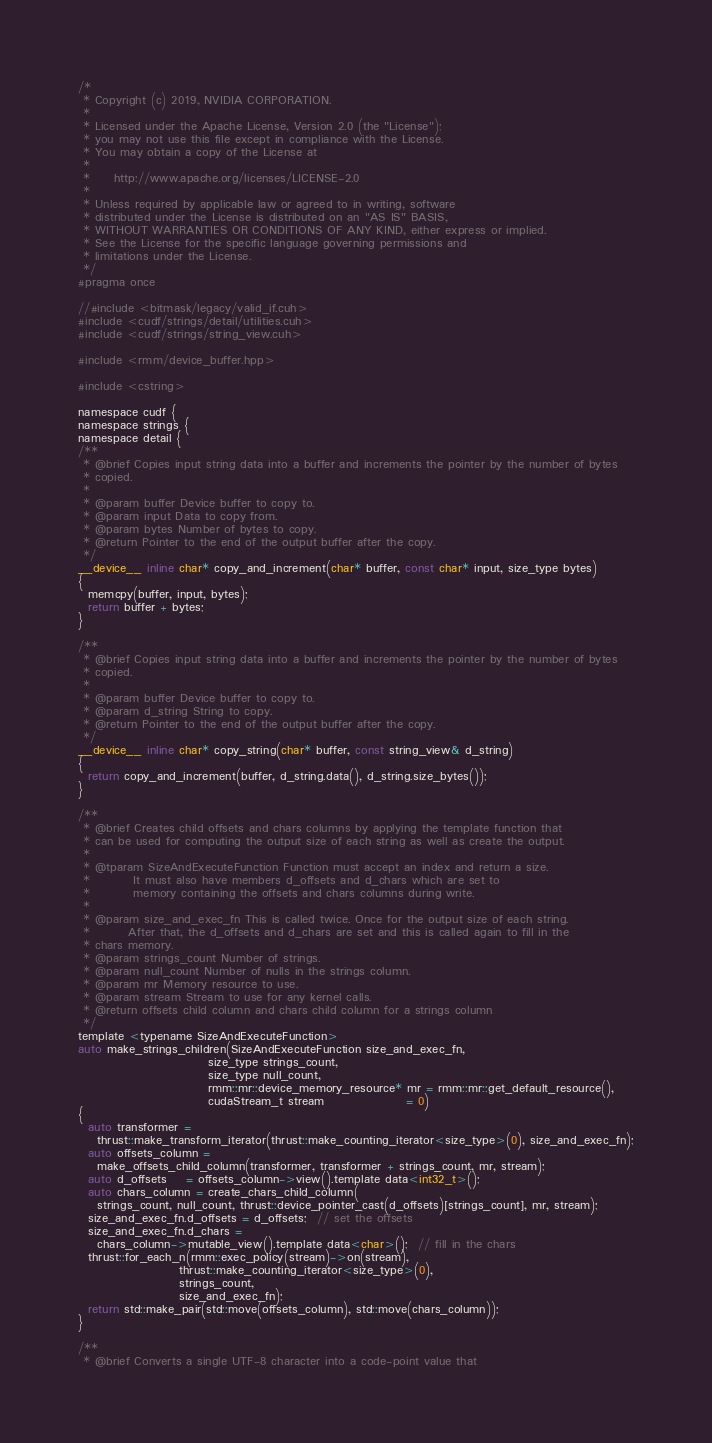<code> <loc_0><loc_0><loc_500><loc_500><_Cuda_>/*
 * Copyright (c) 2019, NVIDIA CORPORATION.
 *
 * Licensed under the Apache License, Version 2.0 (the "License");
 * you may not use this file except in compliance with the License.
 * You may obtain a copy of the License at
 *
 *     http://www.apache.org/licenses/LICENSE-2.0
 *
 * Unless required by applicable law or agreed to in writing, software
 * distributed under the License is distributed on an "AS IS" BASIS,
 * WITHOUT WARRANTIES OR CONDITIONS OF ANY KIND, either express or implied.
 * See the License for the specific language governing permissions and
 * limitations under the License.
 */
#pragma once

//#include <bitmask/legacy/valid_if.cuh>
#include <cudf/strings/detail/utilities.cuh>
#include <cudf/strings/string_view.cuh>

#include <rmm/device_buffer.hpp>

#include <cstring>

namespace cudf {
namespace strings {
namespace detail {
/**
 * @brief Copies input string data into a buffer and increments the pointer by the number of bytes
 * copied.
 *
 * @param buffer Device buffer to copy to.
 * @param input Data to copy from.
 * @param bytes Number of bytes to copy.
 * @return Pointer to the end of the output buffer after the copy.
 */
__device__ inline char* copy_and_increment(char* buffer, const char* input, size_type bytes)
{
  memcpy(buffer, input, bytes);
  return buffer + bytes;
}

/**
 * @brief Copies input string data into a buffer and increments the pointer by the number of bytes
 * copied.
 *
 * @param buffer Device buffer to copy to.
 * @param d_string String to copy.
 * @return Pointer to the end of the output buffer after the copy.
 */
__device__ inline char* copy_string(char* buffer, const string_view& d_string)
{
  return copy_and_increment(buffer, d_string.data(), d_string.size_bytes());
}

/**
 * @brief Creates child offsets and chars columns by applying the template function that
 * can be used for computing the output size of each string as well as create the output.
 *
 * @tparam SizeAndExecuteFunction Function must accept an index and return a size.
 *         It must also have members d_offsets and d_chars which are set to
 *         memory containing the offsets and chars columns during write.
 *
 * @param size_and_exec_fn This is called twice. Once for the output size of each string.
 *        After that, the d_offsets and d_chars are set and this is called again to fill in the
 * chars memory.
 * @param strings_count Number of strings.
 * @param null_count Number of nulls in the strings column.
 * @param mr Memory resource to use.
 * @param stream Stream to use for any kernel calls.
 * @return offsets child column and chars child column for a strings column
 */
template <typename SizeAndExecuteFunction>
auto make_strings_children(SizeAndExecuteFunction size_and_exec_fn,
                           size_type strings_count,
                           size_type null_count,
                           rmm::mr::device_memory_resource* mr = rmm::mr::get_default_resource(),
                           cudaStream_t stream                 = 0)
{
  auto transformer =
    thrust::make_transform_iterator(thrust::make_counting_iterator<size_type>(0), size_and_exec_fn);
  auto offsets_column =
    make_offsets_child_column(transformer, transformer + strings_count, mr, stream);
  auto d_offsets    = offsets_column->view().template data<int32_t>();
  auto chars_column = create_chars_child_column(
    strings_count, null_count, thrust::device_pointer_cast(d_offsets)[strings_count], mr, stream);
  size_and_exec_fn.d_offsets = d_offsets;  // set the offsets
  size_and_exec_fn.d_chars =
    chars_column->mutable_view().template data<char>();  // fill in the chars
  thrust::for_each_n(rmm::exec_policy(stream)->on(stream),
                     thrust::make_counting_iterator<size_type>(0),
                     strings_count,
                     size_and_exec_fn);
  return std::make_pair(std::move(offsets_column), std::move(chars_column));
}

/**
 * @brief Converts a single UTF-8 character into a code-point value that</code> 